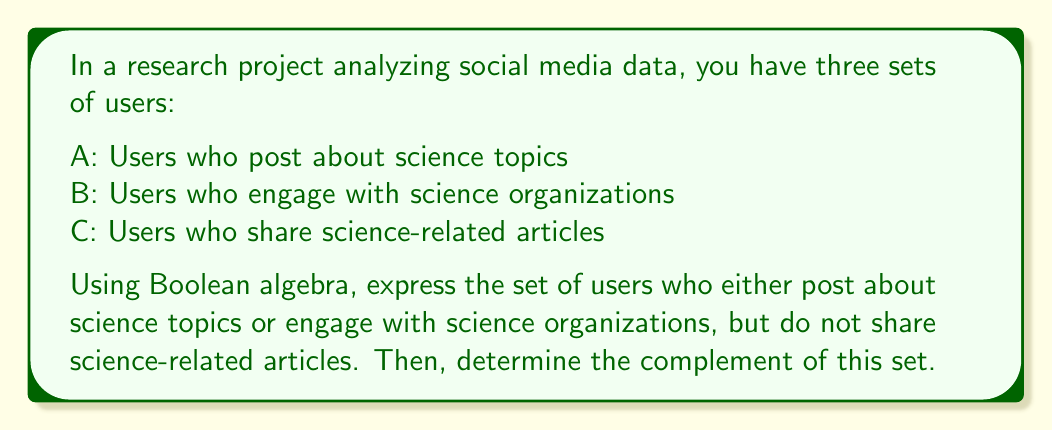Solve this math problem. Let's approach this step-by-step using Boolean algebra:

1) First, let's express the set of users who either post about science topics or engage with science organizations:

   $A \cup B$

2) Now, we need to exclude users who share science-related articles. We can do this by taking the intersection of $(A \cup B)$ with the complement of C:

   $(A \cup B) \cap C'$

   This expression represents the set we're looking for.

3) To find the complement of this set, we can use De Morgan's laws:

   $((A \cup B) \cap C')'$

4) Applying De Morgan's law to the outer complement:

   $(A \cup B)' \cup (C')'$

5) Applying De Morgan's law to $(A \cup B)'$:

   $(A' \cap B') \cup C$

This final expression represents the complement of the set we initially found. It describes the set of users who either:
- Do not post about science topics AND do not engage with science organizations, OR
- Share science-related articles

In set theory notation, this can be written as:

$$(A^c \cap B^c) \cup C$$

Where $A^c$, $B^c$ represent the complements of sets A and B respectively.
Answer: $(A^c \cap B^c) \cup C$ 